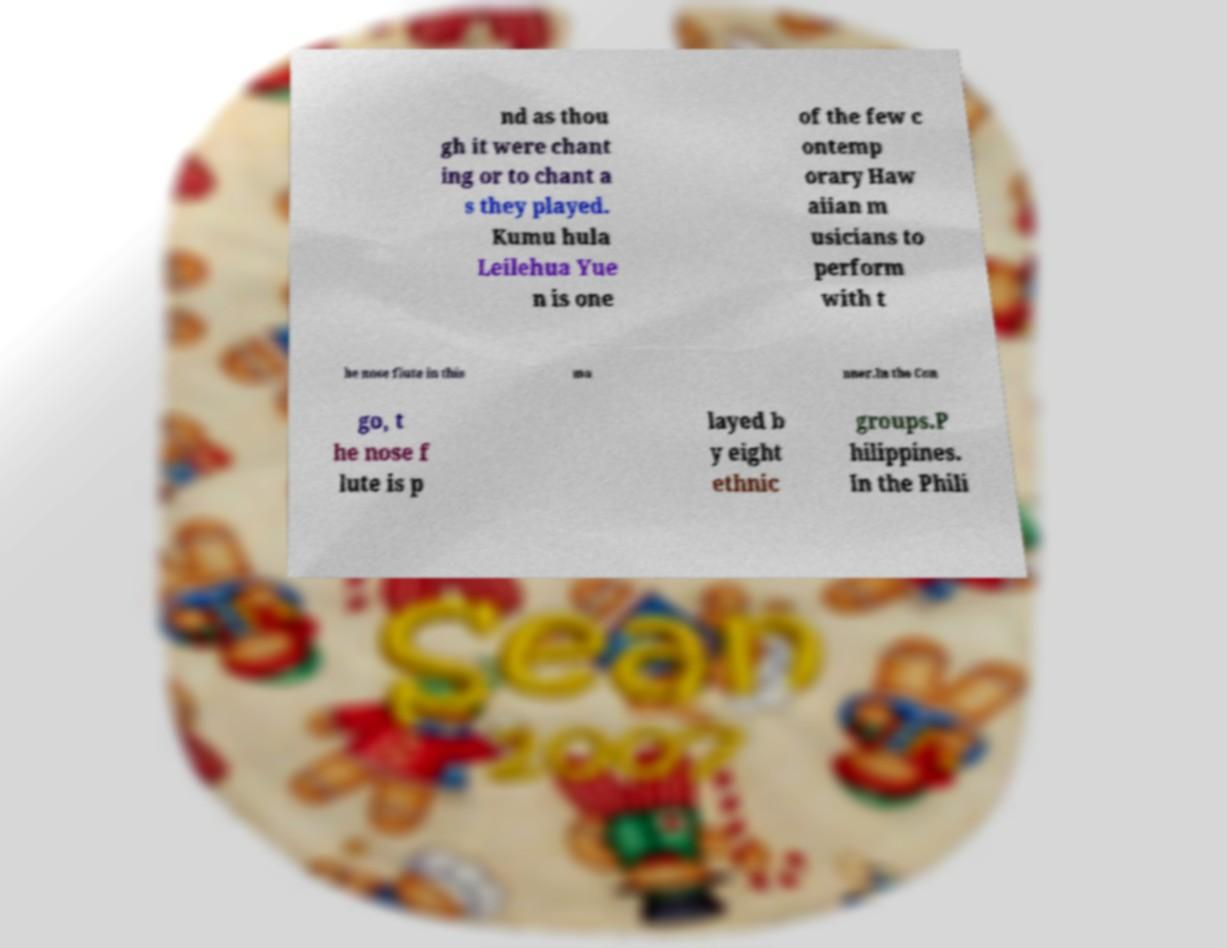Please read and relay the text visible in this image. What does it say? nd as thou gh it were chant ing or to chant a s they played. Kumu hula Leilehua Yue n is one of the few c ontemp orary Haw aiian m usicians to perform with t he nose flute in this ma nner.In the Con go, t he nose f lute is p layed b y eight ethnic groups.P hilippines. In the Phili 